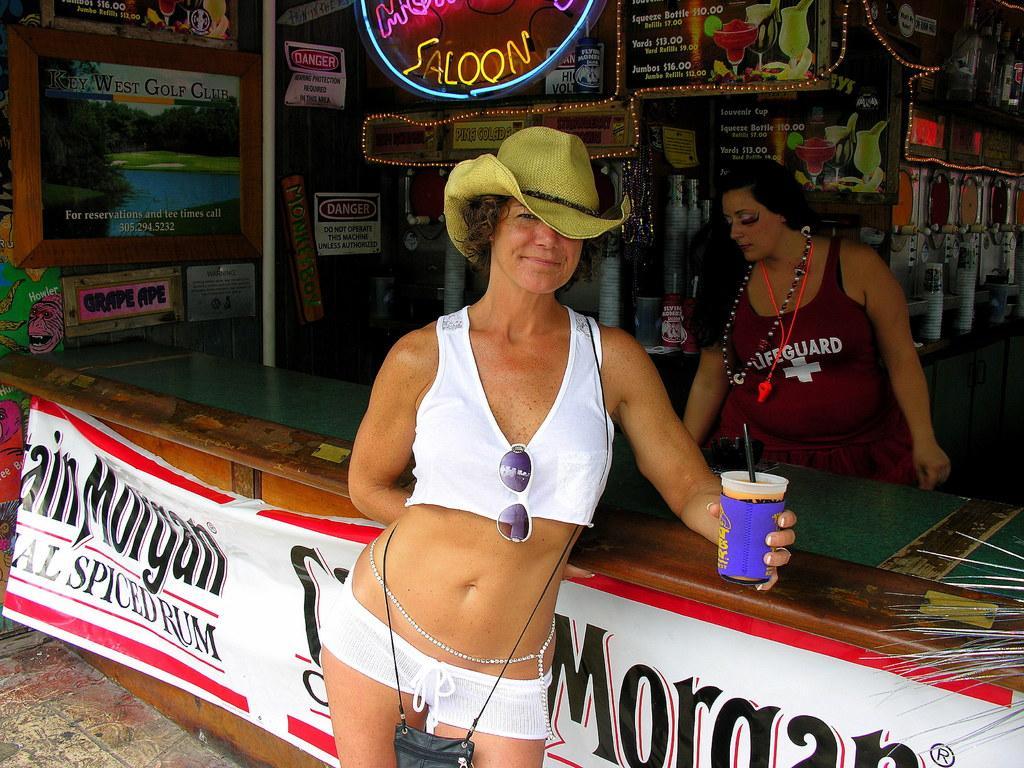Can you describe this image briefly? In the picture we can see a woman standing near the shop desk and she is with white top and google to it and she is holding a glass and wearing a hat which is green in color and in the background we can see a woman standing in the shop and in the shop we can see some things placed with lights. 